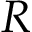<formula> <loc_0><loc_0><loc_500><loc_500>R</formula> 